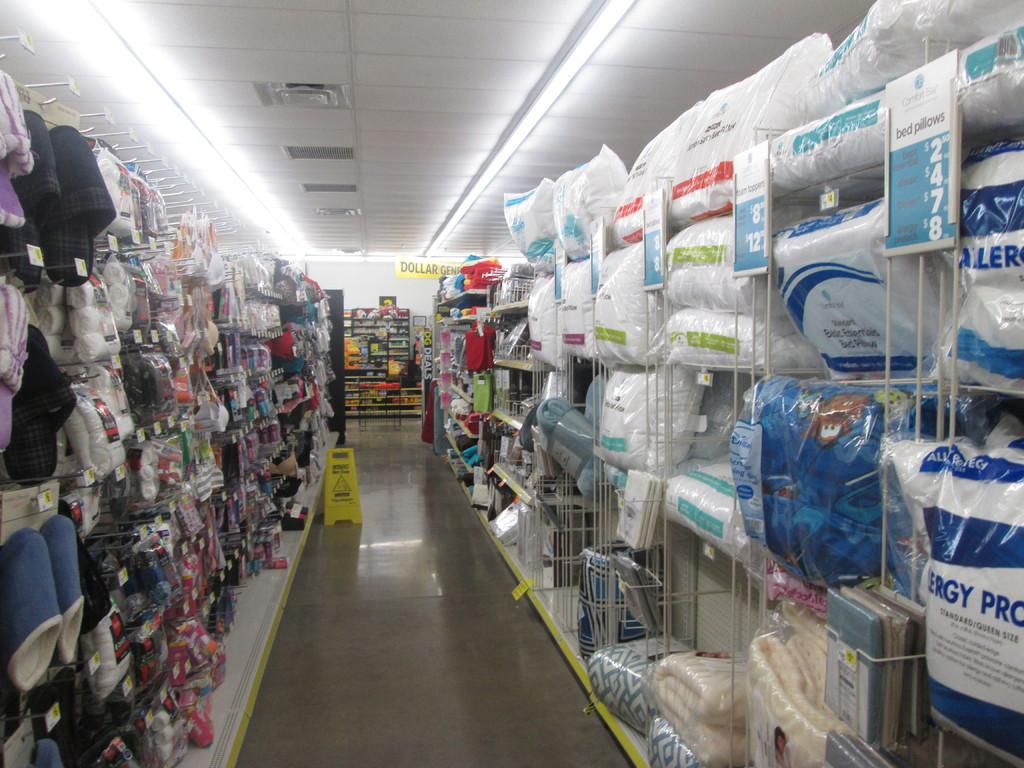What brand are the pillows?
Ensure brevity in your answer.  Comfort bay. 